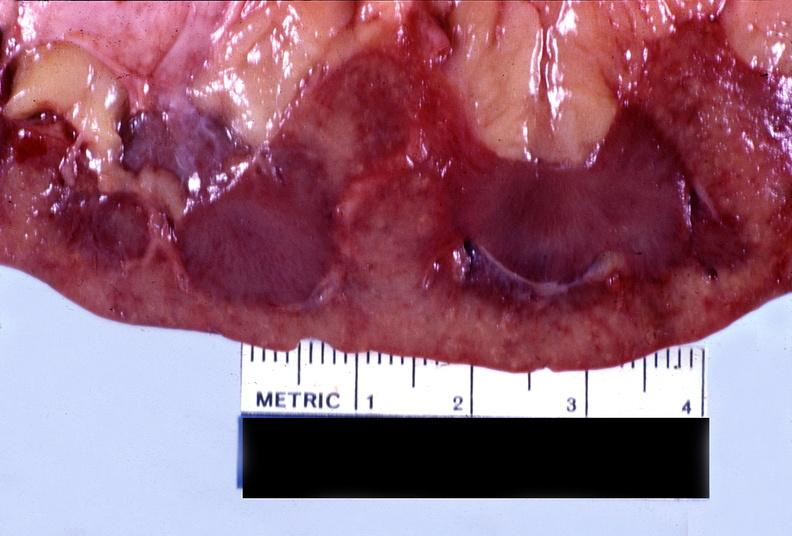where is this?
Answer the question using a single word or phrase. Urinary 